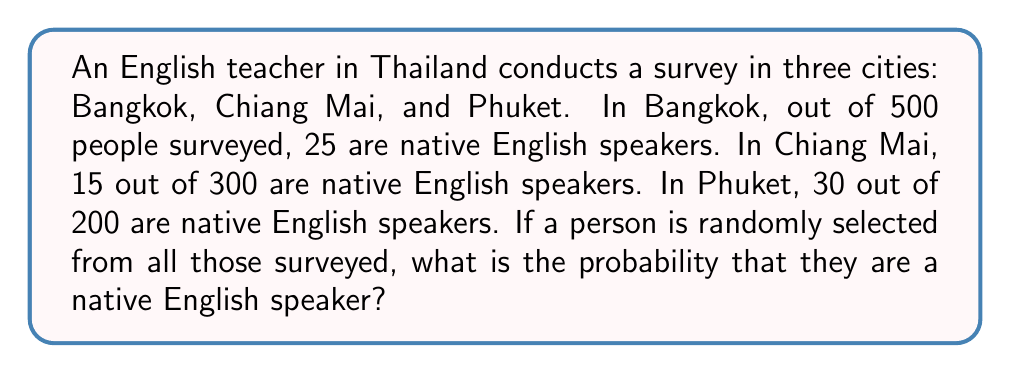Can you answer this question? Let's approach this step-by-step:

1. First, let's calculate the total number of people surveyed:
   Bangkok: 500
   Chiang Mai: 300
   Phuket: 200
   Total: $500 + 300 + 200 = 1000$

2. Now, let's find the total number of native English speakers:
   Bangkok: 25
   Chiang Mai: 15
   Phuket: 30
   Total native English speakers: $25 + 15 + 30 = 70$

3. The probability of selecting a native English speaker is the number of favorable outcomes divided by the total number of possible outcomes:

   $$P(\text{native English speaker}) = \frac{\text{number of native English speakers}}{\text{total number of people surveyed}}$$

4. Substituting our values:

   $$P(\text{native English speaker}) = \frac{70}{1000} = 0.07$$

5. We can express this as a percentage:

   $$0.07 \times 100\% = 7\%$$

Therefore, the probability of randomly selecting a native English speaker from all those surveyed is 0.07 or 7%.
Answer: 0.07 or 7% 